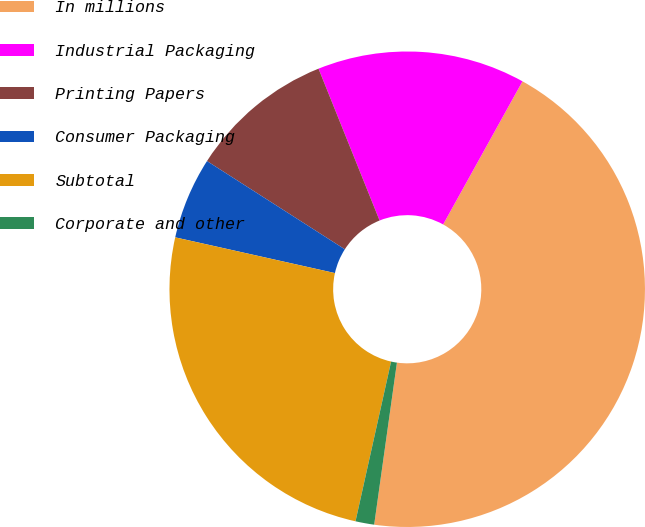Convert chart to OTSL. <chart><loc_0><loc_0><loc_500><loc_500><pie_chart><fcel>In millions<fcel>Industrial Packaging<fcel>Printing Papers<fcel>Consumer Packaging<fcel>Subtotal<fcel>Corporate and other<nl><fcel>44.16%<fcel>14.14%<fcel>9.85%<fcel>5.56%<fcel>25.01%<fcel>1.27%<nl></chart> 